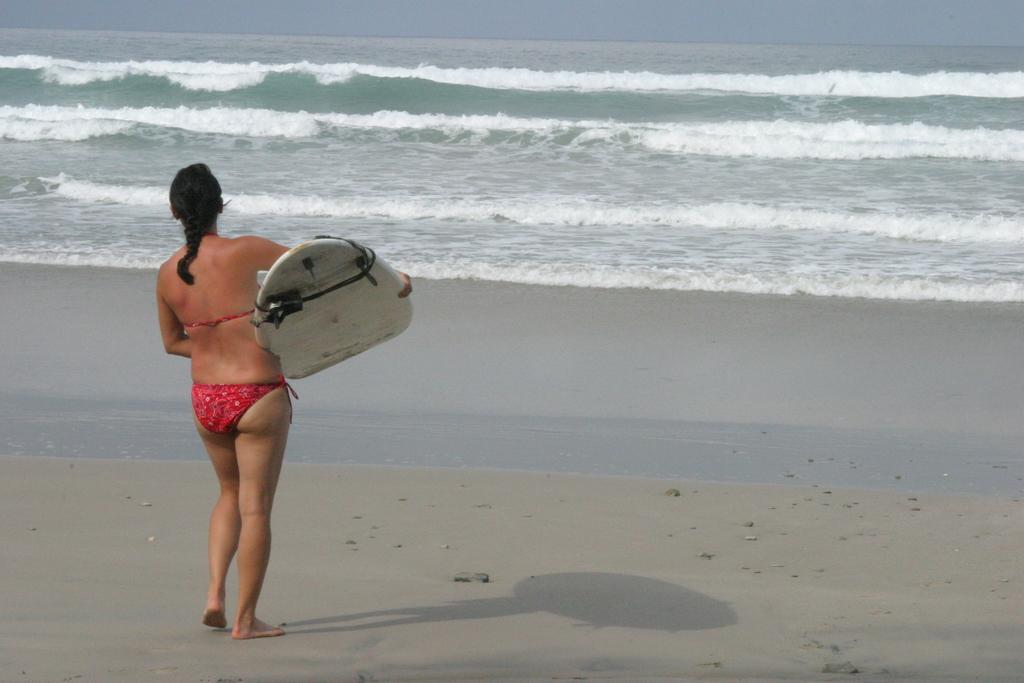Who is the main subject in the image? There is a woman in the image. What is the woman doing in the image? The woman is standing in the image. What is the woman holding in the image? The woman is holding a surfboard in the image. What can be seen in the background of the image? There is water visible in the background of the image. What type of beast can be seen roaming in the image? There is no beast present in the image; it features a woman holding a surfboard with water in the background. 